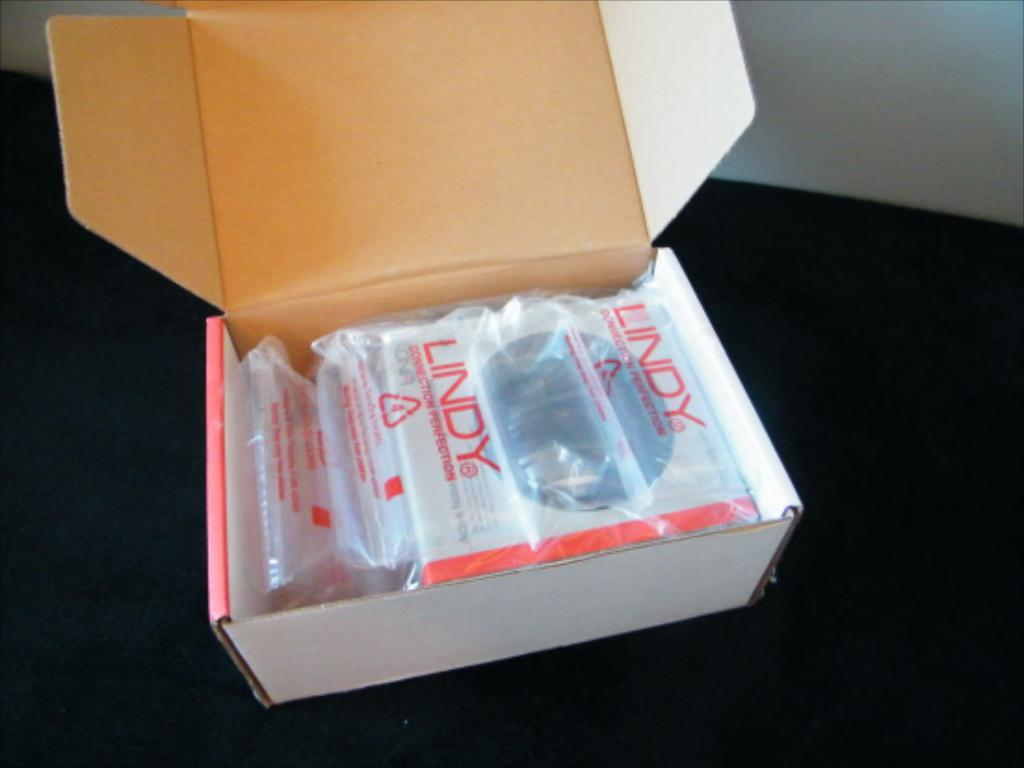<image>
Write a terse but informative summary of the picture. the word lindy is on the box that is brown 